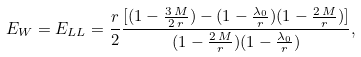<formula> <loc_0><loc_0><loc_500><loc_500>E _ { W } = E _ { L L } = \frac { r } { 2 } \frac { [ ( 1 - \frac { 3 \, M } { 2 \, r } ) - ( 1 - \frac { \lambda _ { 0 } } { r } ) ( 1 - \frac { 2 \, M } { r } ) ] } { ( 1 - \frac { 2 \, M } { r } ) ( 1 - \frac { \lambda _ { 0 } } { r } ) } ,</formula> 